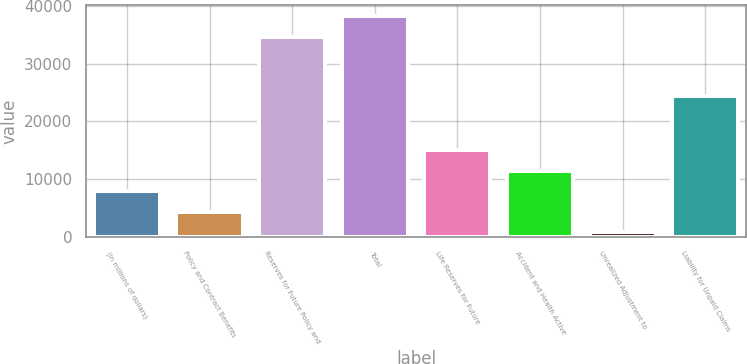<chart> <loc_0><loc_0><loc_500><loc_500><bar_chart><fcel>(in millions of dollars)<fcel>Policy and Contract Benefits<fcel>Reserves for Future Policy and<fcel>Total<fcel>Life Reserves for Future<fcel>Accident and Health Active<fcel>Unrealized Adjustment to<fcel>Liability for Unpaid Claims<nl><fcel>7912.68<fcel>4357.89<fcel>34581.5<fcel>38136.3<fcel>15022.3<fcel>11467.5<fcel>803.1<fcel>24419<nl></chart> 